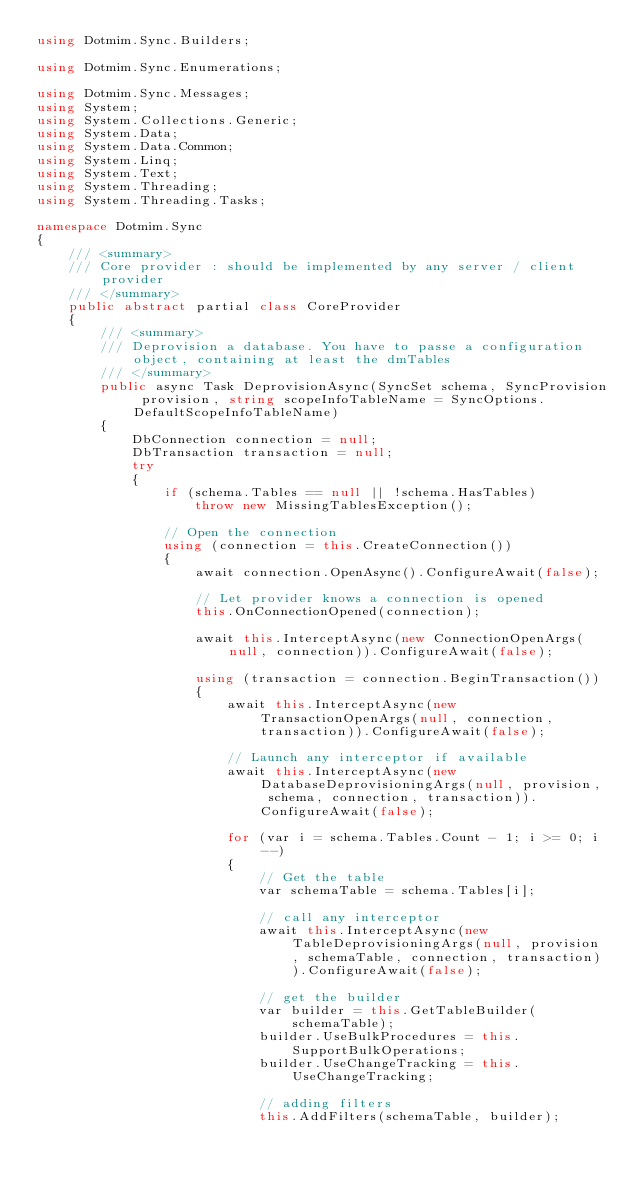<code> <loc_0><loc_0><loc_500><loc_500><_C#_>using Dotmim.Sync.Builders;

using Dotmim.Sync.Enumerations;

using Dotmim.Sync.Messages;
using System;
using System.Collections.Generic;
using System.Data;
using System.Data.Common;
using System.Linq;
using System.Text;
using System.Threading;
using System.Threading.Tasks;

namespace Dotmim.Sync
{
    /// <summary>
    /// Core provider : should be implemented by any server / client provider
    /// </summary>
    public abstract partial class CoreProvider
    {
        /// <summary>
        /// Deprovision a database. You have to passe a configuration object, containing at least the dmTables
        /// </summary>
        public async Task DeprovisionAsync(SyncSet schema, SyncProvision provision, string scopeInfoTableName = SyncOptions.DefaultScopeInfoTableName)
        {
            DbConnection connection = null;
            DbTransaction transaction = null;
            try
            {
                if (schema.Tables == null || !schema.HasTables)
                    throw new MissingTablesException();

                // Open the connection
                using (connection = this.CreateConnection())
                {
                    await connection.OpenAsync().ConfigureAwait(false);

                    // Let provider knows a connection is opened
                    this.OnConnectionOpened(connection);

                    await this.InterceptAsync(new ConnectionOpenArgs(null, connection)).ConfigureAwait(false);

                    using (transaction = connection.BeginTransaction())
                    {
                        await this.InterceptAsync(new TransactionOpenArgs(null, connection, transaction)).ConfigureAwait(false);

                        // Launch any interceptor if available
                        await this.InterceptAsync(new DatabaseDeprovisioningArgs(null, provision, schema, connection, transaction)).ConfigureAwait(false);

                        for (var i = schema.Tables.Count - 1; i >= 0; i--)
                        {
                            // Get the table
                            var schemaTable = schema.Tables[i];

                            // call any interceptor
                            await this.InterceptAsync(new TableDeprovisioningArgs(null, provision, schemaTable, connection, transaction)).ConfigureAwait(false);

                            // get the builder
                            var builder = this.GetTableBuilder(schemaTable);
                            builder.UseBulkProcedures = this.SupportBulkOperations;
                            builder.UseChangeTracking = this.UseChangeTracking;

                            // adding filters
                            this.AddFilters(schemaTable, builder);
</code> 